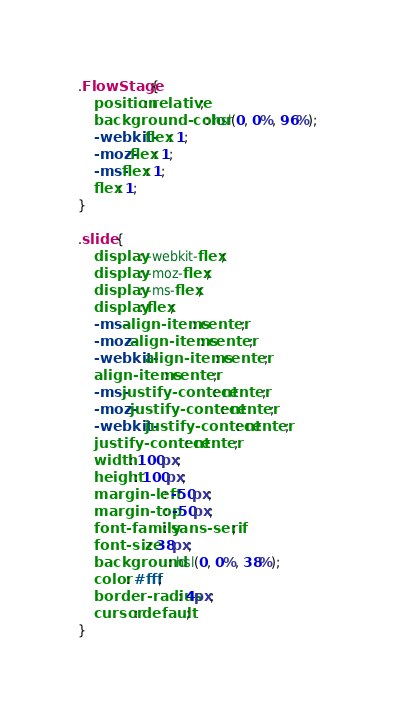Convert code to text. <code><loc_0><loc_0><loc_500><loc_500><_CSS_>.FlowStage {
    position: relative;
    background-color: hsl(0, 0%, 96%);
    -webkit-flex: 1;
    -moz-flex: 1;
    -ms-flex: 1;
    flex: 1;
}

.slide {
    display: -webkit-flex;
    display: -moz-flex;
    display: -ms-flex;
    display: flex;
    -ms-align-items: center;
    -moz-align-items: center;
    -webkit-align-items: center;
    align-items: center;
    -ms-justify-content: center;
    -moz-justify-content: center;
    -webkit-justify-content: center;
    justify-content: center;
    width: 100px;
    height: 100px;
    margin-left: -50px;
    margin-top: -50px;
    font-family: sans-serif;
    font-size: 38px;
    background: hsl(0, 0%, 38%);
    color: #fff;
    border-radius: 4px;
    cursor: default;
}
</code> 